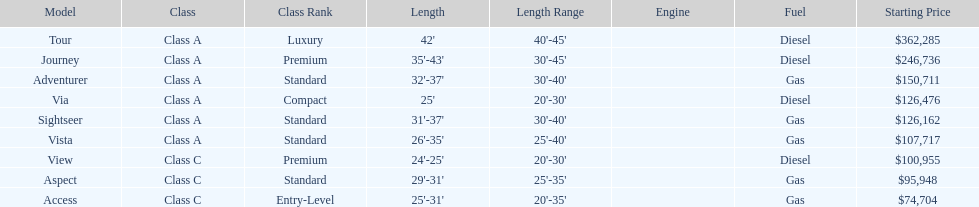Which model had the highest beginning price? Tour. Would you be able to parse every entry in this table? {'header': ['Model', 'Class', 'Class Rank', 'Length', 'Length Range', 'Engine', 'Fuel', 'Starting Price'], 'rows': [['Tour', 'Class A', 'Luxury', "42'", "40'-45'", '', 'Diesel', '$362,285'], ['Journey', 'Class A', 'Premium', "35'-43'", "30'-45'", '', 'Diesel', '$246,736'], ['Adventurer', 'Class A', 'Standard', "32'-37'", "30'-40'", '', 'Gas', '$150,711'], ['Via', 'Class A', 'Compact', "25'", "20'-30'", '', 'Diesel', '$126,476'], ['Sightseer', 'Class A', 'Standard', "31'-37'", "30'-40'", '', 'Gas', '$126,162'], ['Vista', 'Class A', 'Standard', "26'-35'", "25'-40'", '', 'Gas', '$107,717'], ['View', 'Class C', 'Premium', "24'-25'", "20'-30'", '', 'Diesel', '$100,955'], ['Aspect', 'Class C', 'Standard', "29'-31'", "25'-35'", '', 'Gas', '$95,948'], ['Access', 'Class C', 'Entry-Level', "25'-31'", "20'-35'", '', 'Gas', '$74,704']]} 